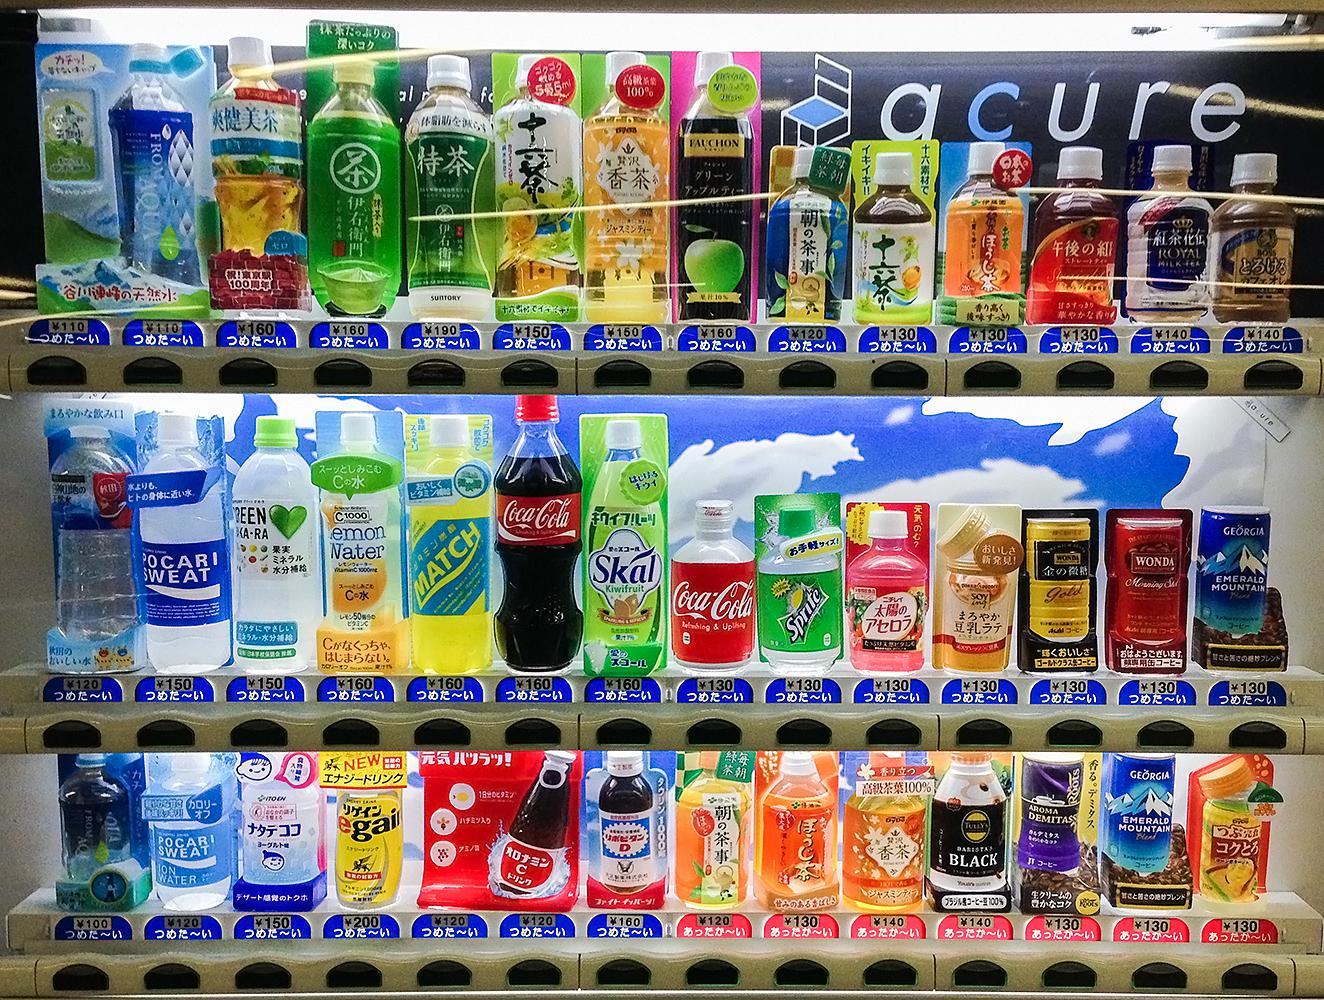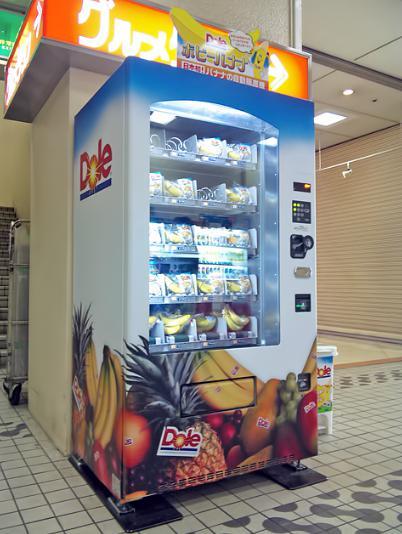The first image is the image on the left, the second image is the image on the right. For the images displayed, is the sentence "The right image only has one vending machine." factually correct? Answer yes or no. Yes. The first image is the image on the left, the second image is the image on the right. Considering the images on both sides, is "At least one image contains a vending machine that is mostly red in color." valid? Answer yes or no. No. 